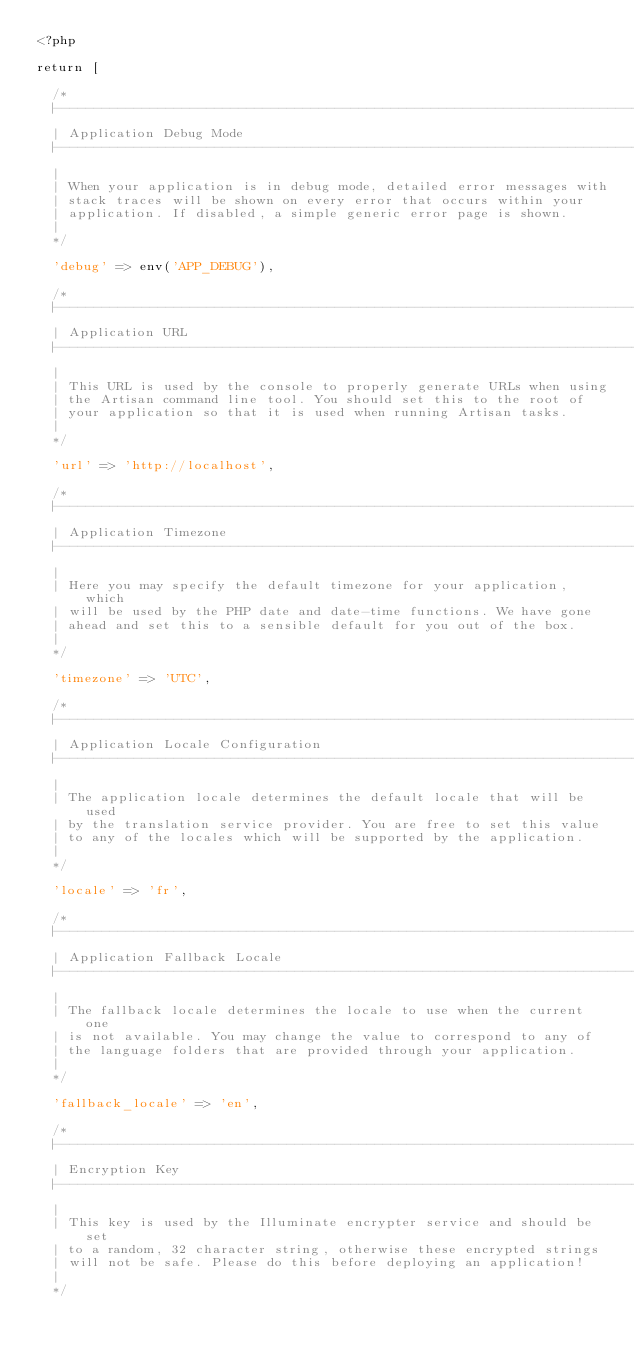Convert code to text. <code><loc_0><loc_0><loc_500><loc_500><_PHP_><?php

return [

	/*
	|--------------------------------------------------------------------------
	| Application Debug Mode
	|--------------------------------------------------------------------------
	|
	| When your application is in debug mode, detailed error messages with
	| stack traces will be shown on every error that occurs within your
	| application. If disabled, a simple generic error page is shown.
	|
	*/

	'debug' => env('APP_DEBUG'),

	/*
	|--------------------------------------------------------------------------
	| Application URL
	|--------------------------------------------------------------------------
	|
	| This URL is used by the console to properly generate URLs when using
	| the Artisan command line tool. You should set this to the root of
	| your application so that it is used when running Artisan tasks.
	|
	*/

	'url' => 'http://localhost',

	/*
	|--------------------------------------------------------------------------
	| Application Timezone
	|--------------------------------------------------------------------------
	|
	| Here you may specify the default timezone for your application, which
	| will be used by the PHP date and date-time functions. We have gone
	| ahead and set this to a sensible default for you out of the box.
	|
	*/

	'timezone' => 'UTC',

	/*
	|--------------------------------------------------------------------------
	| Application Locale Configuration
	|--------------------------------------------------------------------------
	|
	| The application locale determines the default locale that will be used
	| by the translation service provider. You are free to set this value
	| to any of the locales which will be supported by the application.
	|
	*/

	'locale' => 'fr',

	/*
	|--------------------------------------------------------------------------
	| Application Fallback Locale
	|--------------------------------------------------------------------------
	|
	| The fallback locale determines the locale to use when the current one
	| is not available. You may change the value to correspond to any of
	| the language folders that are provided through your application.
	|
	*/

	'fallback_locale' => 'en',

	/*
	|--------------------------------------------------------------------------
	| Encryption Key
	|--------------------------------------------------------------------------
	|
	| This key is used by the Illuminate encrypter service and should be set
	| to a random, 32 character string, otherwise these encrypted strings
	| will not be safe. Please do this before deploying an application!
	|
	*/
</code> 